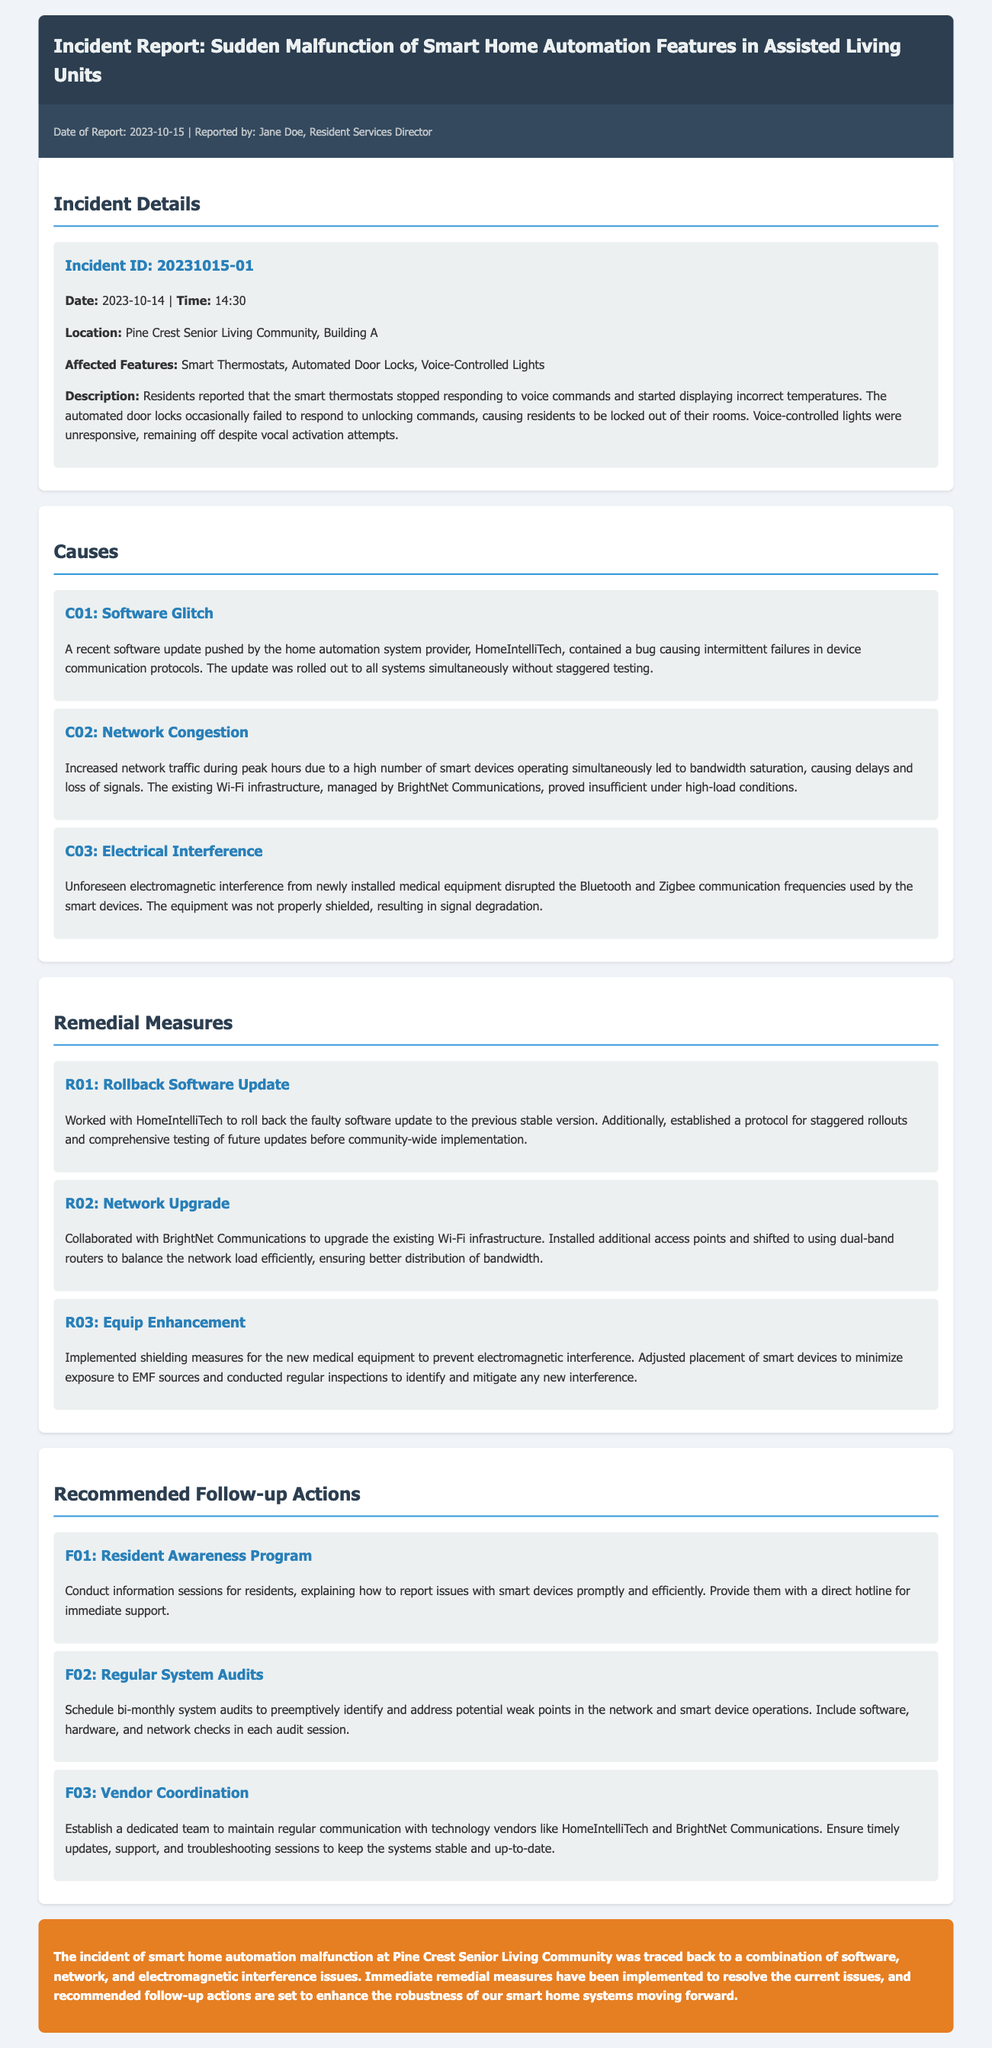What is the incident ID? The incident ID is mentioned in the "Incident Details" section, which identifies the specific incident for tracking purposes.
Answer: 20231015-01 What date did the incident occur? The date of the incident is stated in the "Incident Details" section, providing clarity on when the issue arose.
Answer: 2023-10-14 What are the affected features? The affected features are specifically listed in the "Incident Details" section, indicating which smart home automation systems were malfunctioning.
Answer: Smart Thermostats, Automated Door Locks, Voice-Controlled Lights What caused the software malfunction? The document lists the causes under the "Causes" section, where specific problems leading to the malfunction are detailed.
Answer: Software Glitch What remedial measure was taken for the network issue? The "Remedial Measures" section outlines the steps taken to rectify the identified problems, particularly regarding network issues.
Answer: Network Upgrade What is the recommendation for resident awareness? The recommended follow-up actions include specific initiatives aimed at improving communication and reporting by residents.
Answer: Resident Awareness Program What role did electromagnetic interference play? The causes mention specific issues affecting device communication, highlighting the effects of interference on smart devices.
Answer: Electrical Interference How often will system audits be conducted? The recommended follow-up actions outline the frequency of checks to ensure system stability and performance.
Answer: Bi-monthly Who reported the incident? The report includes the name of the individual responsible for documenting and presenting the incident details.
Answer: Jane Doe 